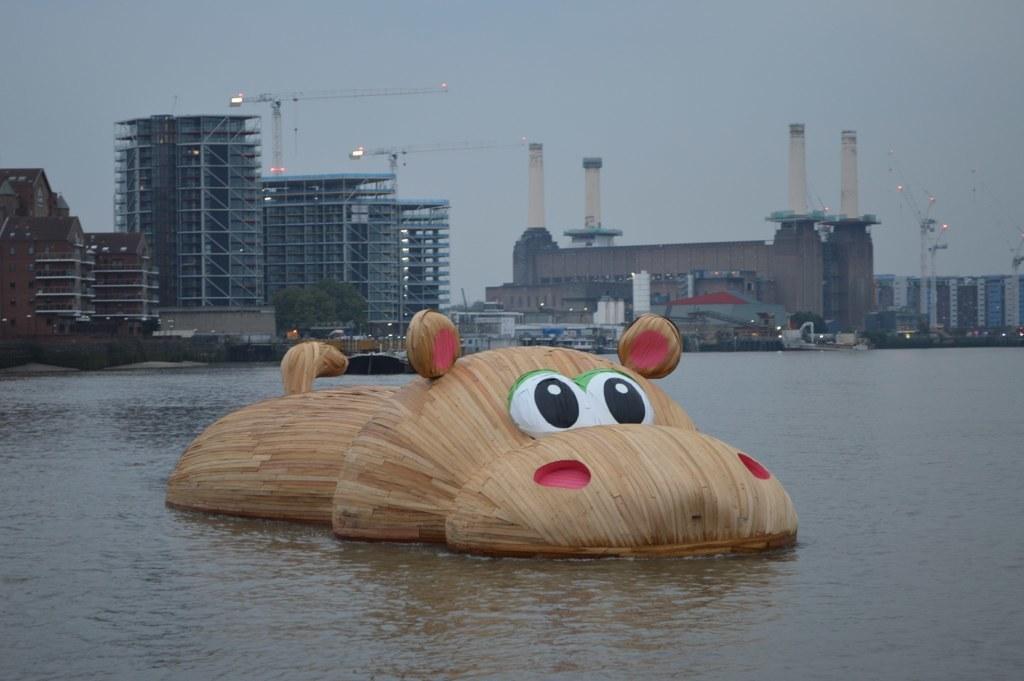In one or two sentences, can you explain what this image depicts? In the foreground of the picture there is a hippopotamus made of wood in the water. In the background there are buildings, trees, lights and cranes. Sky is cloudy. 